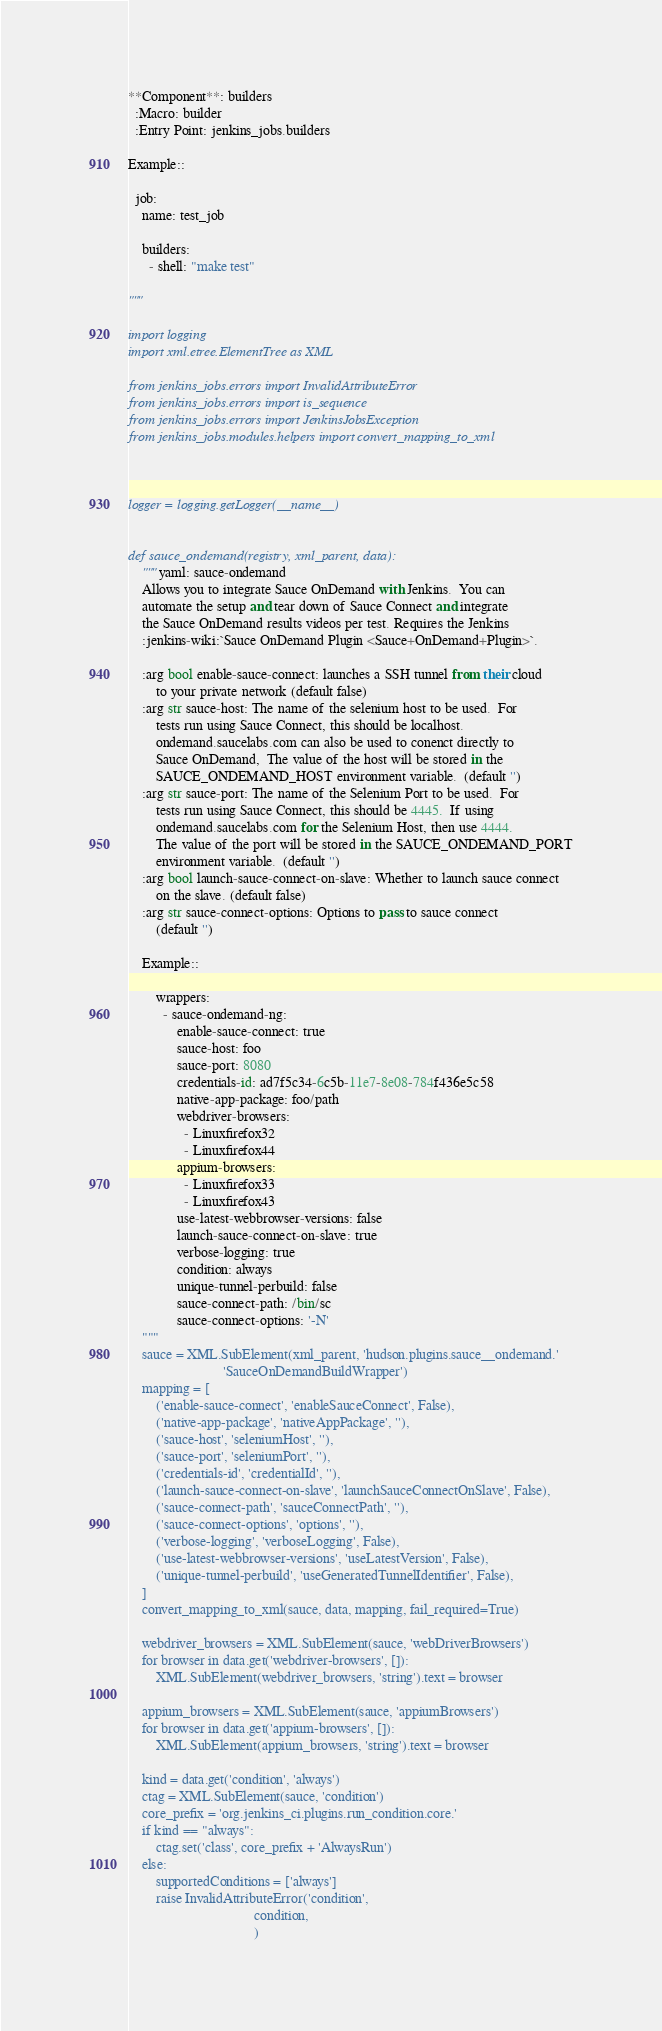<code> <loc_0><loc_0><loc_500><loc_500><_Python_>
**Component**: builders
  :Macro: builder
  :Entry Point: jenkins_jobs.builders

Example::

  job:
    name: test_job

    builders:
      - shell: "make test"

"""

import logging
import xml.etree.ElementTree as XML

from jenkins_jobs.errors import InvalidAttributeError
from jenkins_jobs.errors import is_sequence
from jenkins_jobs.errors import JenkinsJobsException
from jenkins_jobs.modules.helpers import convert_mapping_to_xml



logger = logging.getLogger(__name__)


def sauce_ondemand(registry, xml_parent, data):
    """yaml: sauce-ondemand
    Allows you to integrate Sauce OnDemand with Jenkins.  You can
    automate the setup and tear down of Sauce Connect and integrate
    the Sauce OnDemand results videos per test. Requires the Jenkins
    :jenkins-wiki:`Sauce OnDemand Plugin <Sauce+OnDemand+Plugin>`.

    :arg bool enable-sauce-connect: launches a SSH tunnel from their cloud
        to your private network (default false)
    :arg str sauce-host: The name of the selenium host to be used.  For
        tests run using Sauce Connect, this should be localhost.
        ondemand.saucelabs.com can also be used to conenct directly to
        Sauce OnDemand,  The value of the host will be stored in the
        SAUCE_ONDEMAND_HOST environment variable.  (default '')
    :arg str sauce-port: The name of the Selenium Port to be used.  For
        tests run using Sauce Connect, this should be 4445.  If using
        ondemand.saucelabs.com for the Selenium Host, then use 4444.
        The value of the port will be stored in the SAUCE_ONDEMAND_PORT
        environment variable.  (default '')
    :arg bool launch-sauce-connect-on-slave: Whether to launch sauce connect
        on the slave. (default false)
    :arg str sauce-connect-options: Options to pass to sauce connect
        (default '')

    Example::

        wrappers:
          - sauce-ondemand-ng:
              enable-sauce-connect: true
              sauce-host: foo
              sauce-port: 8080
              credentials-id: ad7f5c34-6c5b-11e7-8e08-784f436e5c58
              native-app-package: foo/path
              webdriver-browsers:
                - Linuxfirefox32
                - Linuxfirefox44
              appium-browsers:
                - Linuxfirefox33
                - Linuxfirefox43
              use-latest-webbrowser-versions: false
              launch-sauce-connect-on-slave: true
              verbose-logging: true
              condition: always
              unique-tunnel-perbuild: false
              sauce-connect-path: /bin/sc
              sauce-connect-options: '-N'
    """
    sauce = XML.SubElement(xml_parent, 'hudson.plugins.sauce__ondemand.'
                           'SauceOnDemandBuildWrapper')
    mapping = [
        ('enable-sauce-connect', 'enableSauceConnect', False),
        ('native-app-package', 'nativeAppPackage', ''),
        ('sauce-host', 'seleniumHost', ''),
        ('sauce-port', 'seleniumPort', ''),
        ('credentials-id', 'credentialId', ''),
        ('launch-sauce-connect-on-slave', 'launchSauceConnectOnSlave', False),
        ('sauce-connect-path', 'sauceConnectPath', ''),
        ('sauce-connect-options', 'options', ''),
        ('verbose-logging', 'verboseLogging', False),
        ('use-latest-webbrowser-versions', 'useLatestVersion', False),
        ('unique-tunnel-perbuild', 'useGeneratedTunnelIdentifier', False),
    ]
    convert_mapping_to_xml(sauce, data, mapping, fail_required=True)

    webdriver_browsers = XML.SubElement(sauce, 'webDriverBrowsers')
    for browser in data.get('webdriver-browsers', []):
        XML.SubElement(webdriver_browsers, 'string').text = browser

    appium_browsers = XML.SubElement(sauce, 'appiumBrowsers')
    for browser in data.get('appium-browsers', []):
        XML.SubElement(appium_browsers, 'string').text = browser

    kind = data.get('condition', 'always')
    ctag = XML.SubElement(sauce, 'condition')
    core_prefix = 'org.jenkins_ci.plugins.run_condition.core.'
    if kind == "always":
        ctag.set('class', core_prefix + 'AlwaysRun')
    else:
        supportedConditions = ['always']
        raise InvalidAttributeError('condition',
                                    condition,
                                    )
</code> 